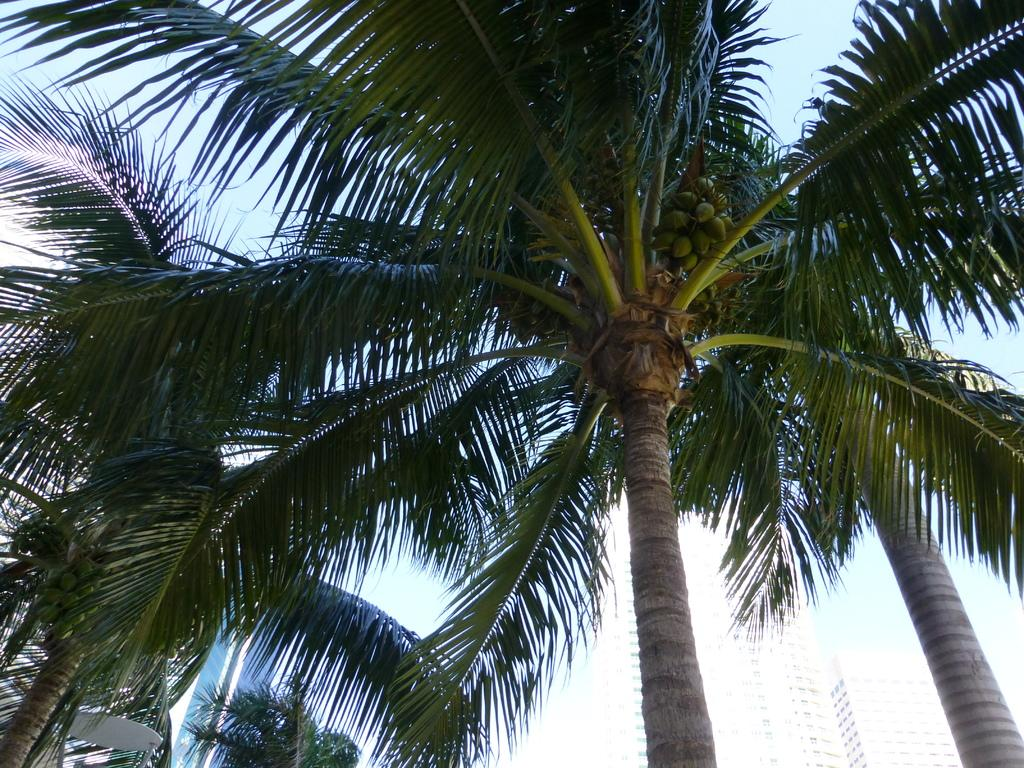What type of vegetation can be seen in the image? There are trees in the image. What type of fruit is present in the image? There is a coconut in the image. What type of man-made structures are visible in the image? There are buildings in the image. Can you tell me how many grapes are hanging from the trees in the image? There are no grapes present in the image; it features trees and a coconut. What type of bike is visible in the image? There is no bike present in the image. 